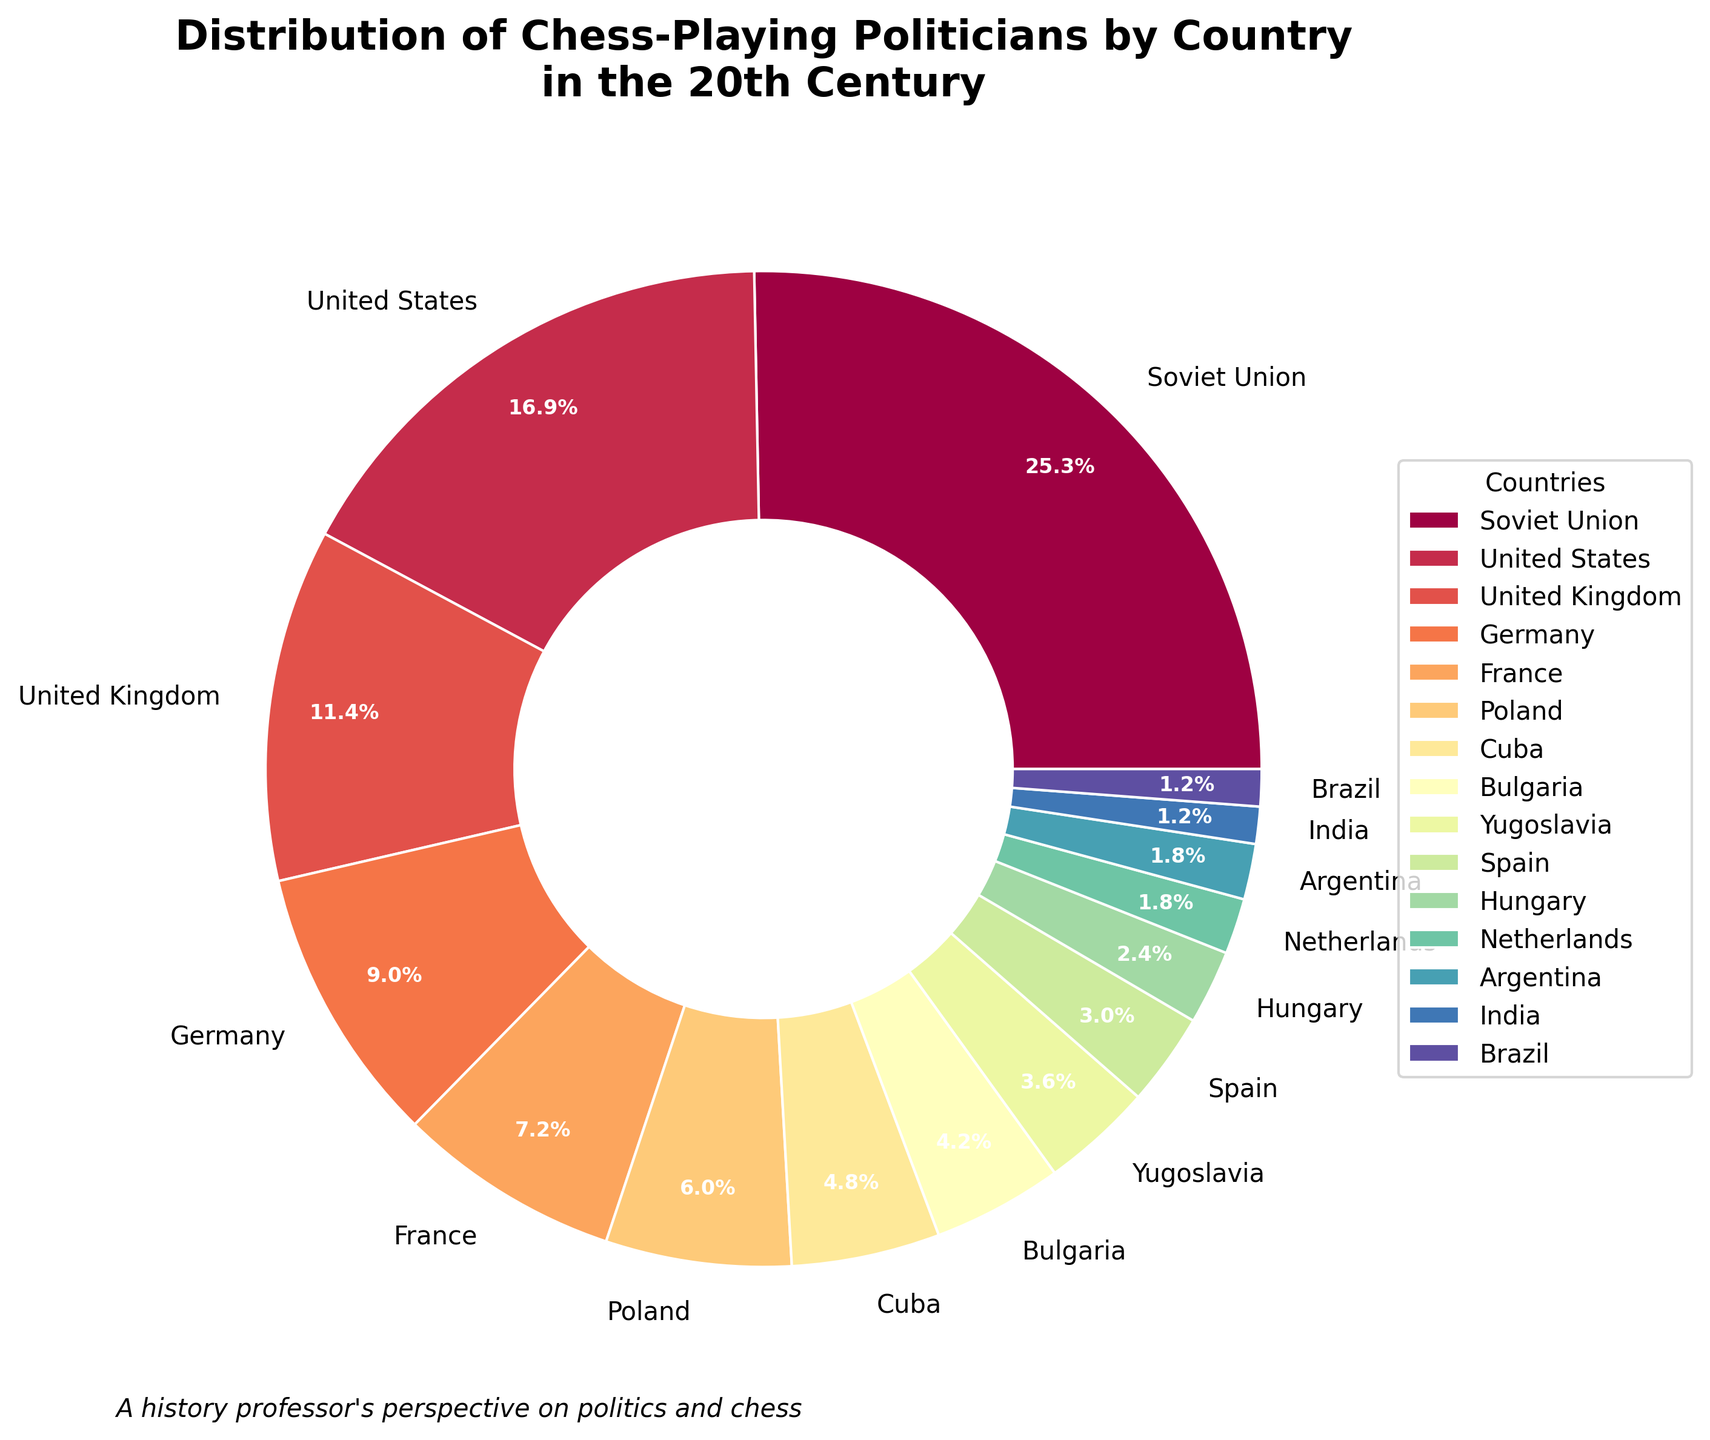What percentage of chess-playing politicians in the 20th century came from the Soviet Union? The Soviet Union's slice shows '42', and the pie chart label indicates its percentage as 38.5%.
Answer: 38.5% Compare the number of chess-playing politicians between the United States and the United Kingdom. Which country has more? The chart shows '28' politicians for the United States and '19' for the United Kingdom. Comparing these values, the United States has more chess-playing politicians.
Answer: United States Which country has the smallest number of chess-playing politicians in the 20th century among the listed countries? The pie chart shows '2' politicians for both India and Brazil, which is the smallest number mentioned in the dataset.
Answer: India and Brazil Sum the number of chess-playing politicians from France, Hungary, and Spain. The pie chart shows '12' for France, '4' for Hungary, and '5' for Spain. Adding these values leads to 12 + 4 + 5 = 21.
Answer: 21 Which countries have less than 10 chess-playing politicians, according to the pie chart? The countries with less than 10 chess-playing politicians are Cuba (8), Bulgaria (7), Yugoslavia (6), Spain (5), Hungary (4), Netherlands (3), Argentina (3), India (2), and Brazil (2).
Answer: Cuba, Bulgaria, Yugoslavia, Spain, Hungary, Netherlands, Argentina, India, Brazil What is the difference between the number of chess-playing politicians from Poland and Germany? Poland has '10' and Germany has '15' chess-playing politicians, so the difference is 15 - 10 = 5.
Answer: 5 Out of Argentina and India, which country has more chess-playing politicians, and by how much? The pie chart shows '3' for Argentina and '2' for India. Argentina has 1 more chess-playing politician than India.
Answer: Argentina by 1 What is the total number of chess-playing politicians in the dataset? Sum all values listed in the pie chart: 42 + 28 + 19 + 15 + 12 + 10 + 8 + 7 + 6 + 5 + 4 + 3 + 3 + 2 + 2 = 166.
Answer: 166 What is the combined percentage representation of Bulgaria, Yugoslavia, and Spain? The chart shows that Bulgaria has 7, Yugoslavia 6, and Spain 5. The percentages are approximately 4.2%, 3.6%, and 3.0%, respectively. Adding these gives 4.2 + 3.6 + 3.0 ≈ 10.8%.
Answer: 10.8% Which country's slice appears to be around the same size as the combined slice of Hungary and the Netherlands? Hungary has 4, and the Netherlands has 3, summing to 4 + 3 = 7. This is close to the Bulgaria slice, which also has 7.
Answer: Bulgaria 